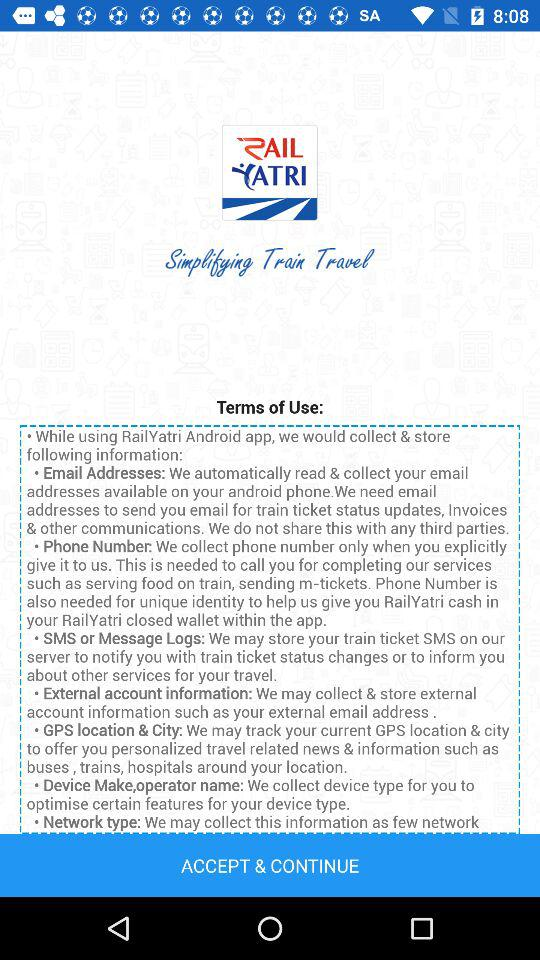What is the application name? The application name is "RailYatri". 